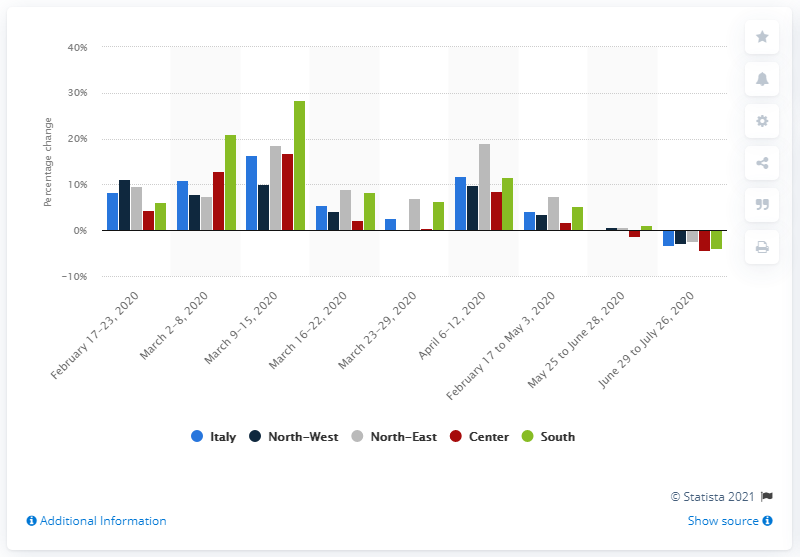Mention a couple of crucial points in this snapshot. During the week between February and March 2020, the retail sales value in the South grew by 28.4%. 